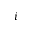<formula> <loc_0><loc_0><loc_500><loc_500>i</formula> 